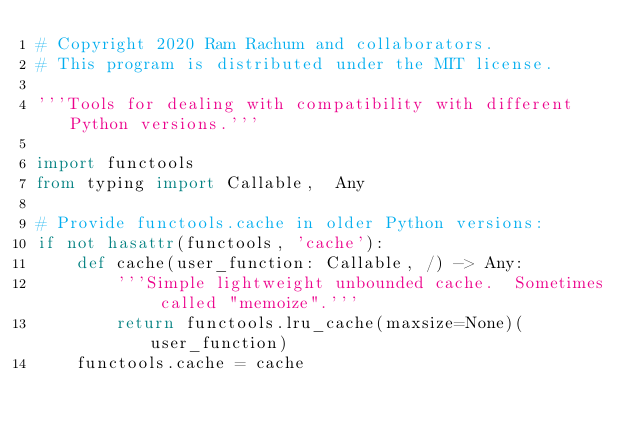<code> <loc_0><loc_0><loc_500><loc_500><_Python_># Copyright 2020 Ram Rachum and collaborators.
# This program is distributed under the MIT license.

'''Tools for dealing with compatibility with different Python versions.'''

import functools
from typing import Callable,  Any

# Provide functools.cache in older Python versions:
if not hasattr(functools, 'cache'):
    def cache(user_function: Callable, /) -> Any:
        '''Simple lightweight unbounded cache.  Sometimes called "memoize".'''
        return functools.lru_cache(maxsize=None)(user_function)
    functools.cache = cache
</code> 